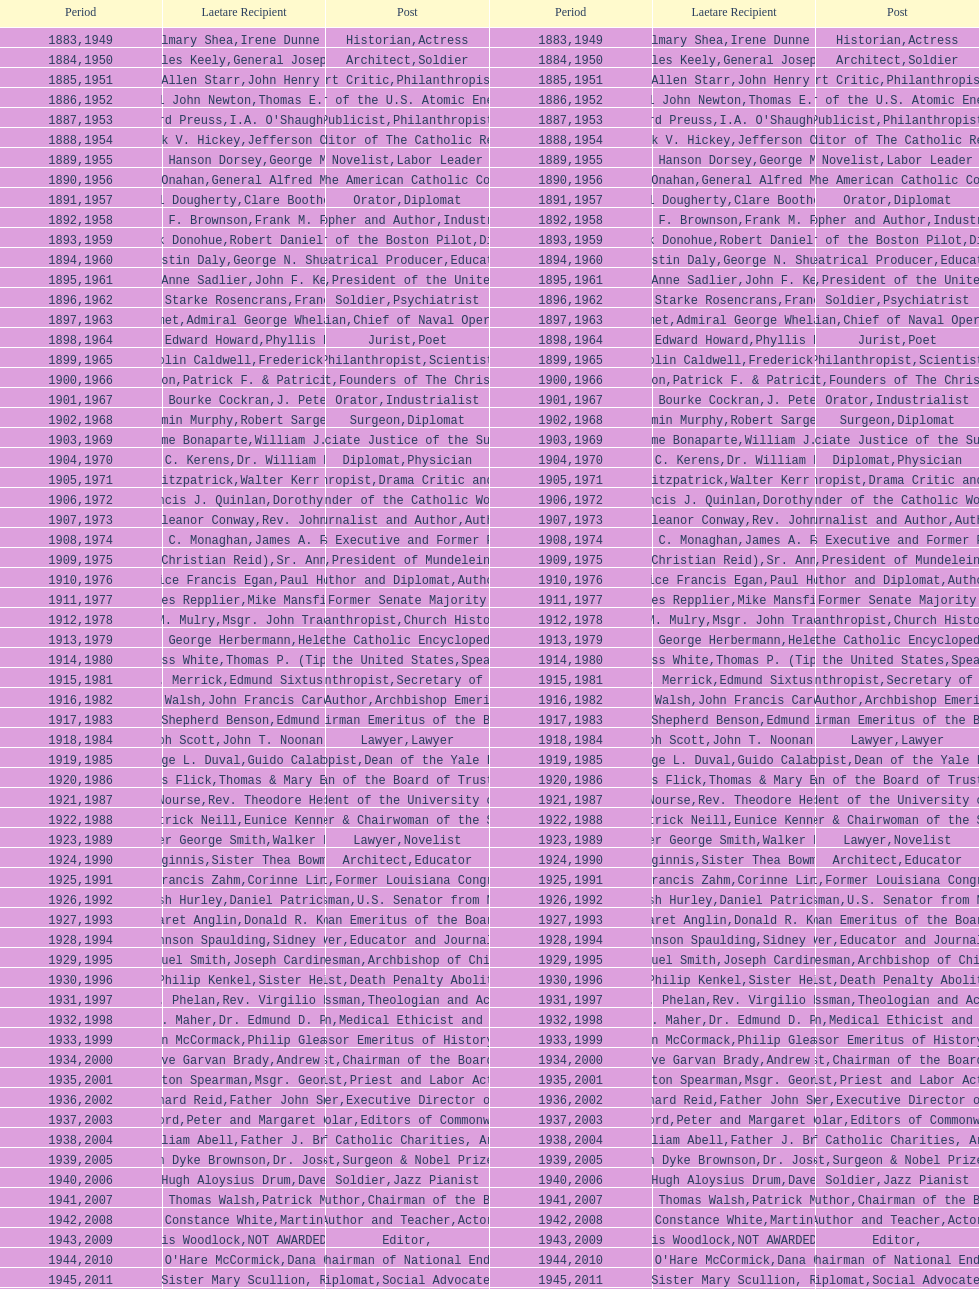What are the number of laetare medalist that held a diplomat position? 8. 